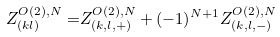Convert formula to latex. <formula><loc_0><loc_0><loc_500><loc_500>Z ^ { O ( 2 ) , N } _ { ( k l ) } = & Z ^ { O ( 2 ) , N } _ { ( k , l , + ) } + ( - 1 ) ^ { N + 1 } Z ^ { O ( 2 ) , N } _ { ( k , l , - ) }</formula> 